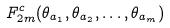<formula> <loc_0><loc_0><loc_500><loc_500>F _ { 2 m } ^ { c } ( \theta _ { a _ { 1 } } , \theta _ { a _ { 2 } } , \dots , \theta _ { a _ { m } } )</formula> 